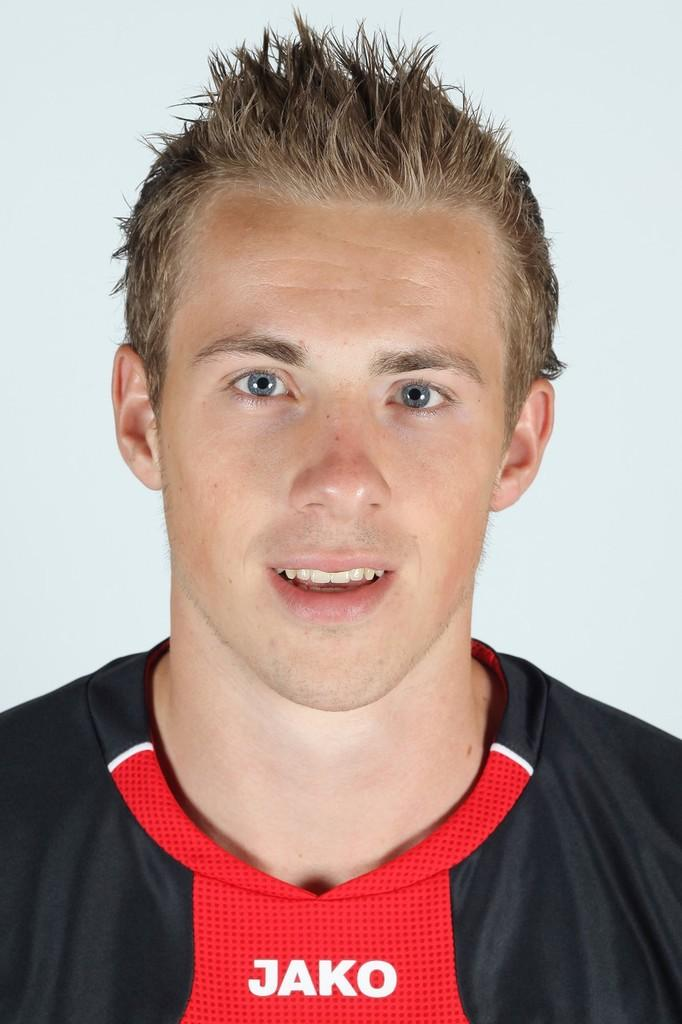<image>
Render a clear and concise summary of the photo. a young man wearing a  black and red JAKO jersey 